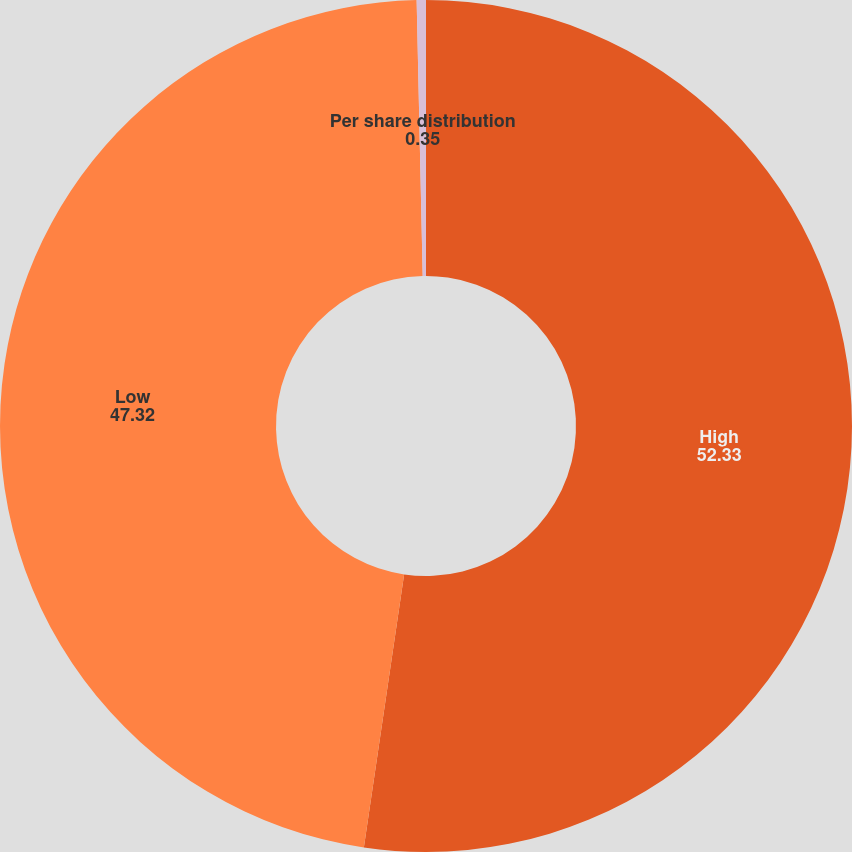Convert chart to OTSL. <chart><loc_0><loc_0><loc_500><loc_500><pie_chart><fcel>High<fcel>Low<fcel>Per share distribution<nl><fcel>52.33%<fcel>47.32%<fcel>0.35%<nl></chart> 